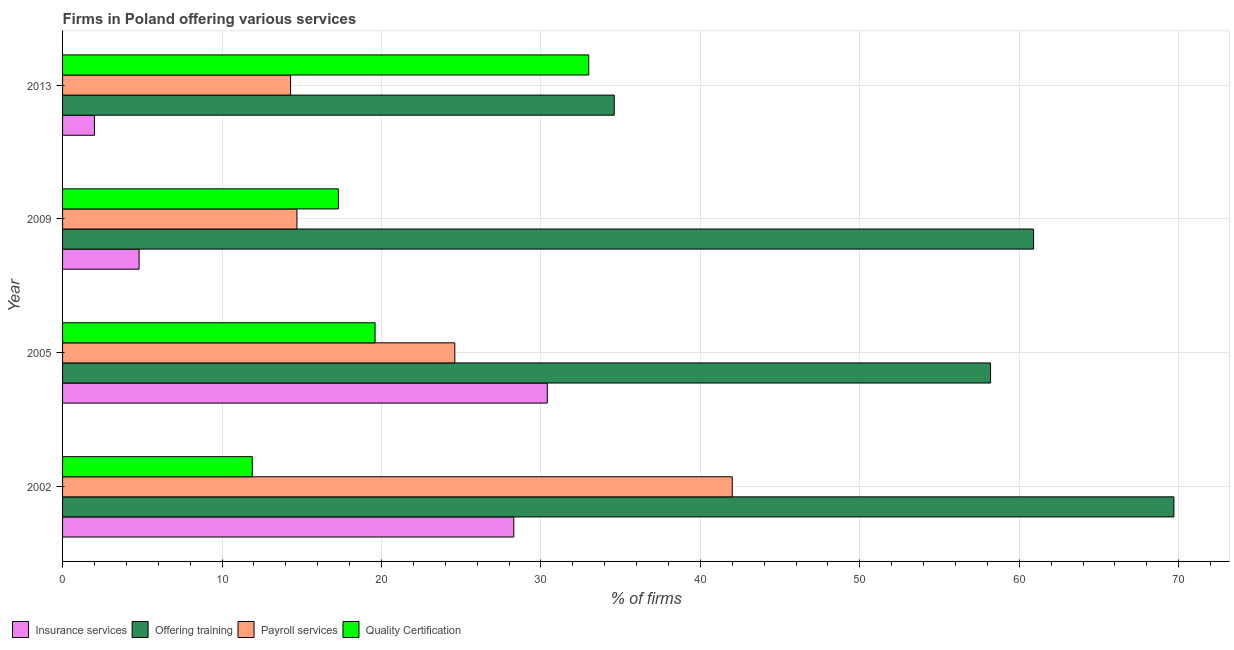How many different coloured bars are there?
Your answer should be compact. 4. Are the number of bars per tick equal to the number of legend labels?
Keep it short and to the point. Yes. Are the number of bars on each tick of the Y-axis equal?
Your answer should be very brief. Yes. In how many cases, is the number of bars for a given year not equal to the number of legend labels?
Your response must be concise. 0. What is the percentage of firms offering training in 2002?
Ensure brevity in your answer.  69.7. Across all years, what is the maximum percentage of firms offering insurance services?
Provide a short and direct response. 30.4. Across all years, what is the minimum percentage of firms offering training?
Give a very brief answer. 34.6. In which year was the percentage of firms offering payroll services minimum?
Offer a very short reply. 2013. What is the total percentage of firms offering quality certification in the graph?
Make the answer very short. 81.8. What is the difference between the percentage of firms offering payroll services in 2002 and that in 2013?
Give a very brief answer. 27.7. What is the difference between the percentage of firms offering quality certification in 2005 and the percentage of firms offering payroll services in 2002?
Ensure brevity in your answer.  -22.4. What is the average percentage of firms offering quality certification per year?
Your answer should be compact. 20.45. In the year 2005, what is the difference between the percentage of firms offering training and percentage of firms offering quality certification?
Your response must be concise. 38.6. What is the ratio of the percentage of firms offering quality certification in 2009 to that in 2013?
Provide a succinct answer. 0.52. What is the difference between the highest and the second highest percentage of firms offering insurance services?
Your answer should be compact. 2.1. What is the difference between the highest and the lowest percentage of firms offering quality certification?
Provide a succinct answer. 21.1. Is it the case that in every year, the sum of the percentage of firms offering payroll services and percentage of firms offering training is greater than the sum of percentage of firms offering insurance services and percentage of firms offering quality certification?
Provide a succinct answer. No. What does the 1st bar from the top in 2005 represents?
Make the answer very short. Quality Certification. What does the 3rd bar from the bottom in 2013 represents?
Make the answer very short. Payroll services. Is it the case that in every year, the sum of the percentage of firms offering insurance services and percentage of firms offering training is greater than the percentage of firms offering payroll services?
Ensure brevity in your answer.  Yes. Are all the bars in the graph horizontal?
Your answer should be compact. Yes. Are the values on the major ticks of X-axis written in scientific E-notation?
Your response must be concise. No. Does the graph contain any zero values?
Provide a short and direct response. No. Where does the legend appear in the graph?
Your answer should be very brief. Bottom left. How many legend labels are there?
Keep it short and to the point. 4. What is the title of the graph?
Give a very brief answer. Firms in Poland offering various services . What is the label or title of the X-axis?
Your response must be concise. % of firms. What is the % of firms in Insurance services in 2002?
Your answer should be compact. 28.3. What is the % of firms in Offering training in 2002?
Offer a very short reply. 69.7. What is the % of firms in Insurance services in 2005?
Your answer should be compact. 30.4. What is the % of firms of Offering training in 2005?
Ensure brevity in your answer.  58.2. What is the % of firms in Payroll services in 2005?
Provide a succinct answer. 24.6. What is the % of firms in Quality Certification in 2005?
Your response must be concise. 19.6. What is the % of firms in Insurance services in 2009?
Keep it short and to the point. 4.8. What is the % of firms of Offering training in 2009?
Offer a very short reply. 60.9. What is the % of firms of Payroll services in 2009?
Your answer should be compact. 14.7. What is the % of firms in Quality Certification in 2009?
Offer a very short reply. 17.3. What is the % of firms of Offering training in 2013?
Provide a short and direct response. 34.6. What is the % of firms in Quality Certification in 2013?
Offer a terse response. 33. Across all years, what is the maximum % of firms of Insurance services?
Give a very brief answer. 30.4. Across all years, what is the maximum % of firms of Offering training?
Your response must be concise. 69.7. Across all years, what is the maximum % of firms in Payroll services?
Your response must be concise. 42. Across all years, what is the maximum % of firms in Quality Certification?
Ensure brevity in your answer.  33. Across all years, what is the minimum % of firms in Insurance services?
Make the answer very short. 2. Across all years, what is the minimum % of firms in Offering training?
Your answer should be compact. 34.6. What is the total % of firms in Insurance services in the graph?
Give a very brief answer. 65.5. What is the total % of firms in Offering training in the graph?
Give a very brief answer. 223.4. What is the total % of firms of Payroll services in the graph?
Your response must be concise. 95.6. What is the total % of firms in Quality Certification in the graph?
Ensure brevity in your answer.  81.8. What is the difference between the % of firms in Offering training in 2002 and that in 2005?
Your response must be concise. 11.5. What is the difference between the % of firms of Quality Certification in 2002 and that in 2005?
Your response must be concise. -7.7. What is the difference between the % of firms in Insurance services in 2002 and that in 2009?
Your response must be concise. 23.5. What is the difference between the % of firms in Offering training in 2002 and that in 2009?
Ensure brevity in your answer.  8.8. What is the difference between the % of firms of Payroll services in 2002 and that in 2009?
Your answer should be compact. 27.3. What is the difference between the % of firms of Quality Certification in 2002 and that in 2009?
Ensure brevity in your answer.  -5.4. What is the difference between the % of firms of Insurance services in 2002 and that in 2013?
Provide a short and direct response. 26.3. What is the difference between the % of firms in Offering training in 2002 and that in 2013?
Keep it short and to the point. 35.1. What is the difference between the % of firms in Payroll services in 2002 and that in 2013?
Offer a very short reply. 27.7. What is the difference between the % of firms in Quality Certification in 2002 and that in 2013?
Your answer should be very brief. -21.1. What is the difference between the % of firms in Insurance services in 2005 and that in 2009?
Make the answer very short. 25.6. What is the difference between the % of firms of Offering training in 2005 and that in 2009?
Offer a very short reply. -2.7. What is the difference between the % of firms in Payroll services in 2005 and that in 2009?
Keep it short and to the point. 9.9. What is the difference between the % of firms of Quality Certification in 2005 and that in 2009?
Provide a short and direct response. 2.3. What is the difference between the % of firms in Insurance services in 2005 and that in 2013?
Offer a terse response. 28.4. What is the difference between the % of firms of Offering training in 2005 and that in 2013?
Keep it short and to the point. 23.6. What is the difference between the % of firms of Offering training in 2009 and that in 2013?
Offer a very short reply. 26.3. What is the difference between the % of firms in Payroll services in 2009 and that in 2013?
Your answer should be compact. 0.4. What is the difference between the % of firms of Quality Certification in 2009 and that in 2013?
Provide a succinct answer. -15.7. What is the difference between the % of firms in Insurance services in 2002 and the % of firms in Offering training in 2005?
Provide a succinct answer. -29.9. What is the difference between the % of firms of Insurance services in 2002 and the % of firms of Quality Certification in 2005?
Offer a terse response. 8.7. What is the difference between the % of firms of Offering training in 2002 and the % of firms of Payroll services in 2005?
Offer a terse response. 45.1. What is the difference between the % of firms in Offering training in 2002 and the % of firms in Quality Certification in 2005?
Provide a succinct answer. 50.1. What is the difference between the % of firms of Payroll services in 2002 and the % of firms of Quality Certification in 2005?
Give a very brief answer. 22.4. What is the difference between the % of firms in Insurance services in 2002 and the % of firms in Offering training in 2009?
Provide a short and direct response. -32.6. What is the difference between the % of firms of Insurance services in 2002 and the % of firms of Payroll services in 2009?
Keep it short and to the point. 13.6. What is the difference between the % of firms of Offering training in 2002 and the % of firms of Quality Certification in 2009?
Offer a very short reply. 52.4. What is the difference between the % of firms in Payroll services in 2002 and the % of firms in Quality Certification in 2009?
Provide a short and direct response. 24.7. What is the difference between the % of firms of Insurance services in 2002 and the % of firms of Payroll services in 2013?
Your answer should be compact. 14. What is the difference between the % of firms of Insurance services in 2002 and the % of firms of Quality Certification in 2013?
Offer a very short reply. -4.7. What is the difference between the % of firms in Offering training in 2002 and the % of firms in Payroll services in 2013?
Offer a terse response. 55.4. What is the difference between the % of firms in Offering training in 2002 and the % of firms in Quality Certification in 2013?
Provide a short and direct response. 36.7. What is the difference between the % of firms of Insurance services in 2005 and the % of firms of Offering training in 2009?
Keep it short and to the point. -30.5. What is the difference between the % of firms in Insurance services in 2005 and the % of firms in Quality Certification in 2009?
Offer a very short reply. 13.1. What is the difference between the % of firms of Offering training in 2005 and the % of firms of Payroll services in 2009?
Provide a succinct answer. 43.5. What is the difference between the % of firms in Offering training in 2005 and the % of firms in Quality Certification in 2009?
Provide a short and direct response. 40.9. What is the difference between the % of firms of Insurance services in 2005 and the % of firms of Payroll services in 2013?
Keep it short and to the point. 16.1. What is the difference between the % of firms of Offering training in 2005 and the % of firms of Payroll services in 2013?
Make the answer very short. 43.9. What is the difference between the % of firms of Offering training in 2005 and the % of firms of Quality Certification in 2013?
Make the answer very short. 25.2. What is the difference between the % of firms of Insurance services in 2009 and the % of firms of Offering training in 2013?
Your response must be concise. -29.8. What is the difference between the % of firms of Insurance services in 2009 and the % of firms of Quality Certification in 2013?
Your answer should be compact. -28.2. What is the difference between the % of firms of Offering training in 2009 and the % of firms of Payroll services in 2013?
Provide a short and direct response. 46.6. What is the difference between the % of firms in Offering training in 2009 and the % of firms in Quality Certification in 2013?
Provide a short and direct response. 27.9. What is the difference between the % of firms in Payroll services in 2009 and the % of firms in Quality Certification in 2013?
Make the answer very short. -18.3. What is the average % of firms of Insurance services per year?
Your response must be concise. 16.38. What is the average % of firms of Offering training per year?
Ensure brevity in your answer.  55.85. What is the average % of firms of Payroll services per year?
Provide a succinct answer. 23.9. What is the average % of firms in Quality Certification per year?
Your answer should be compact. 20.45. In the year 2002, what is the difference between the % of firms in Insurance services and % of firms in Offering training?
Provide a short and direct response. -41.4. In the year 2002, what is the difference between the % of firms in Insurance services and % of firms in Payroll services?
Your answer should be compact. -13.7. In the year 2002, what is the difference between the % of firms of Insurance services and % of firms of Quality Certification?
Keep it short and to the point. 16.4. In the year 2002, what is the difference between the % of firms of Offering training and % of firms of Payroll services?
Offer a very short reply. 27.7. In the year 2002, what is the difference between the % of firms in Offering training and % of firms in Quality Certification?
Your response must be concise. 57.8. In the year 2002, what is the difference between the % of firms in Payroll services and % of firms in Quality Certification?
Provide a short and direct response. 30.1. In the year 2005, what is the difference between the % of firms of Insurance services and % of firms of Offering training?
Your response must be concise. -27.8. In the year 2005, what is the difference between the % of firms of Offering training and % of firms of Payroll services?
Offer a very short reply. 33.6. In the year 2005, what is the difference between the % of firms of Offering training and % of firms of Quality Certification?
Your response must be concise. 38.6. In the year 2009, what is the difference between the % of firms of Insurance services and % of firms of Offering training?
Provide a short and direct response. -56.1. In the year 2009, what is the difference between the % of firms in Insurance services and % of firms in Quality Certification?
Give a very brief answer. -12.5. In the year 2009, what is the difference between the % of firms of Offering training and % of firms of Payroll services?
Provide a short and direct response. 46.2. In the year 2009, what is the difference between the % of firms in Offering training and % of firms in Quality Certification?
Keep it short and to the point. 43.6. In the year 2013, what is the difference between the % of firms of Insurance services and % of firms of Offering training?
Offer a terse response. -32.6. In the year 2013, what is the difference between the % of firms in Insurance services and % of firms in Payroll services?
Offer a very short reply. -12.3. In the year 2013, what is the difference between the % of firms of Insurance services and % of firms of Quality Certification?
Ensure brevity in your answer.  -31. In the year 2013, what is the difference between the % of firms in Offering training and % of firms in Payroll services?
Keep it short and to the point. 20.3. In the year 2013, what is the difference between the % of firms in Offering training and % of firms in Quality Certification?
Provide a short and direct response. 1.6. In the year 2013, what is the difference between the % of firms of Payroll services and % of firms of Quality Certification?
Your response must be concise. -18.7. What is the ratio of the % of firms in Insurance services in 2002 to that in 2005?
Offer a terse response. 0.93. What is the ratio of the % of firms of Offering training in 2002 to that in 2005?
Make the answer very short. 1.2. What is the ratio of the % of firms in Payroll services in 2002 to that in 2005?
Offer a very short reply. 1.71. What is the ratio of the % of firms in Quality Certification in 2002 to that in 2005?
Ensure brevity in your answer.  0.61. What is the ratio of the % of firms of Insurance services in 2002 to that in 2009?
Make the answer very short. 5.9. What is the ratio of the % of firms in Offering training in 2002 to that in 2009?
Provide a succinct answer. 1.14. What is the ratio of the % of firms of Payroll services in 2002 to that in 2009?
Give a very brief answer. 2.86. What is the ratio of the % of firms in Quality Certification in 2002 to that in 2009?
Your answer should be compact. 0.69. What is the ratio of the % of firms in Insurance services in 2002 to that in 2013?
Give a very brief answer. 14.15. What is the ratio of the % of firms in Offering training in 2002 to that in 2013?
Your answer should be very brief. 2.01. What is the ratio of the % of firms in Payroll services in 2002 to that in 2013?
Ensure brevity in your answer.  2.94. What is the ratio of the % of firms in Quality Certification in 2002 to that in 2013?
Provide a short and direct response. 0.36. What is the ratio of the % of firms in Insurance services in 2005 to that in 2009?
Your answer should be compact. 6.33. What is the ratio of the % of firms of Offering training in 2005 to that in 2009?
Your answer should be compact. 0.96. What is the ratio of the % of firms of Payroll services in 2005 to that in 2009?
Give a very brief answer. 1.67. What is the ratio of the % of firms of Quality Certification in 2005 to that in 2009?
Give a very brief answer. 1.13. What is the ratio of the % of firms in Insurance services in 2005 to that in 2013?
Your response must be concise. 15.2. What is the ratio of the % of firms of Offering training in 2005 to that in 2013?
Your response must be concise. 1.68. What is the ratio of the % of firms in Payroll services in 2005 to that in 2013?
Ensure brevity in your answer.  1.72. What is the ratio of the % of firms of Quality Certification in 2005 to that in 2013?
Provide a short and direct response. 0.59. What is the ratio of the % of firms in Insurance services in 2009 to that in 2013?
Your answer should be compact. 2.4. What is the ratio of the % of firms in Offering training in 2009 to that in 2013?
Offer a very short reply. 1.76. What is the ratio of the % of firms of Payroll services in 2009 to that in 2013?
Your answer should be very brief. 1.03. What is the ratio of the % of firms in Quality Certification in 2009 to that in 2013?
Give a very brief answer. 0.52. What is the difference between the highest and the second highest % of firms in Offering training?
Keep it short and to the point. 8.8. What is the difference between the highest and the second highest % of firms of Payroll services?
Keep it short and to the point. 17.4. What is the difference between the highest and the lowest % of firms of Insurance services?
Give a very brief answer. 28.4. What is the difference between the highest and the lowest % of firms of Offering training?
Offer a very short reply. 35.1. What is the difference between the highest and the lowest % of firms in Payroll services?
Keep it short and to the point. 27.7. What is the difference between the highest and the lowest % of firms in Quality Certification?
Offer a terse response. 21.1. 